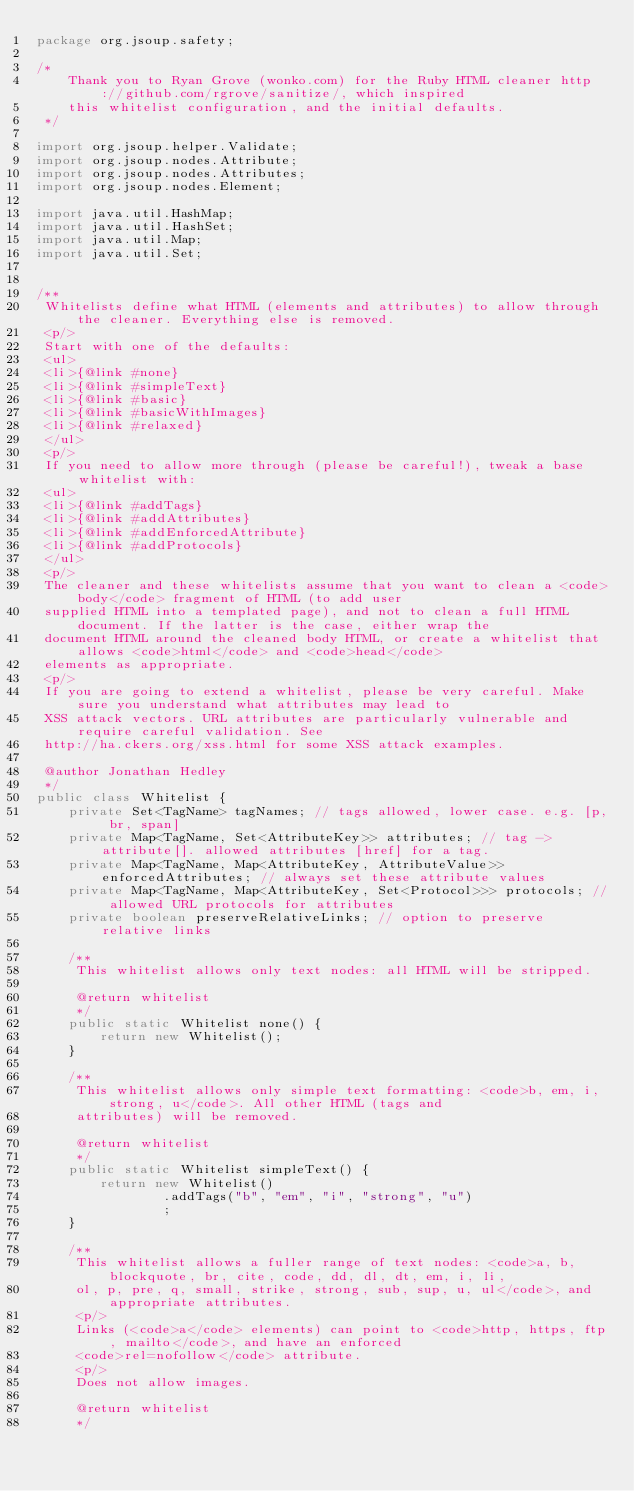Convert code to text. <code><loc_0><loc_0><loc_500><loc_500><_Java_>package org.jsoup.safety;

/*
    Thank you to Ryan Grove (wonko.com) for the Ruby HTML cleaner http://github.com/rgrove/sanitize/, which inspired
    this whitelist configuration, and the initial defaults.
 */

import org.jsoup.helper.Validate;
import org.jsoup.nodes.Attribute;
import org.jsoup.nodes.Attributes;
import org.jsoup.nodes.Element;

import java.util.HashMap;
import java.util.HashSet;
import java.util.Map;
import java.util.Set;


/**
 Whitelists define what HTML (elements and attributes) to allow through the cleaner. Everything else is removed.
 <p/>
 Start with one of the defaults:
 <ul>
 <li>{@link #none}
 <li>{@link #simpleText}
 <li>{@link #basic}
 <li>{@link #basicWithImages}
 <li>{@link #relaxed}
 </ul>
 <p/>
 If you need to allow more through (please be careful!), tweak a base whitelist with:
 <ul>
 <li>{@link #addTags}
 <li>{@link #addAttributes}
 <li>{@link #addEnforcedAttribute}
 <li>{@link #addProtocols}
 </ul>
 <p/>
 The cleaner and these whitelists assume that you want to clean a <code>body</code> fragment of HTML (to add user
 supplied HTML into a templated page), and not to clean a full HTML document. If the latter is the case, either wrap the
 document HTML around the cleaned body HTML, or create a whitelist that allows <code>html</code> and <code>head</code>
 elements as appropriate.
 <p/>
 If you are going to extend a whitelist, please be very careful. Make sure you understand what attributes may lead to
 XSS attack vectors. URL attributes are particularly vulnerable and require careful validation. See 
 http://ha.ckers.org/xss.html for some XSS attack examples.

 @author Jonathan Hedley
 */
public class Whitelist {
    private Set<TagName> tagNames; // tags allowed, lower case. e.g. [p, br, span]
    private Map<TagName, Set<AttributeKey>> attributes; // tag -> attribute[]. allowed attributes [href] for a tag.
    private Map<TagName, Map<AttributeKey, AttributeValue>> enforcedAttributes; // always set these attribute values
    private Map<TagName, Map<AttributeKey, Set<Protocol>>> protocols; // allowed URL protocols for attributes
    private boolean preserveRelativeLinks; // option to preserve relative links

    /**
     This whitelist allows only text nodes: all HTML will be stripped.

     @return whitelist
     */
    public static Whitelist none() {
        return new Whitelist();
    }

    /**
     This whitelist allows only simple text formatting: <code>b, em, i, strong, u</code>. All other HTML (tags and
     attributes) will be removed.

     @return whitelist
     */
    public static Whitelist simpleText() {
        return new Whitelist()
                .addTags("b", "em", "i", "strong", "u")
                ;
    }

    /**
     This whitelist allows a fuller range of text nodes: <code>a, b, blockquote, br, cite, code, dd, dl, dt, em, i, li,
     ol, p, pre, q, small, strike, strong, sub, sup, u, ul</code>, and appropriate attributes.
     <p/>
     Links (<code>a</code> elements) can point to <code>http, https, ftp, mailto</code>, and have an enforced
     <code>rel=nofollow</code> attribute.
     <p/>
     Does not allow images.

     @return whitelist
     */</code> 